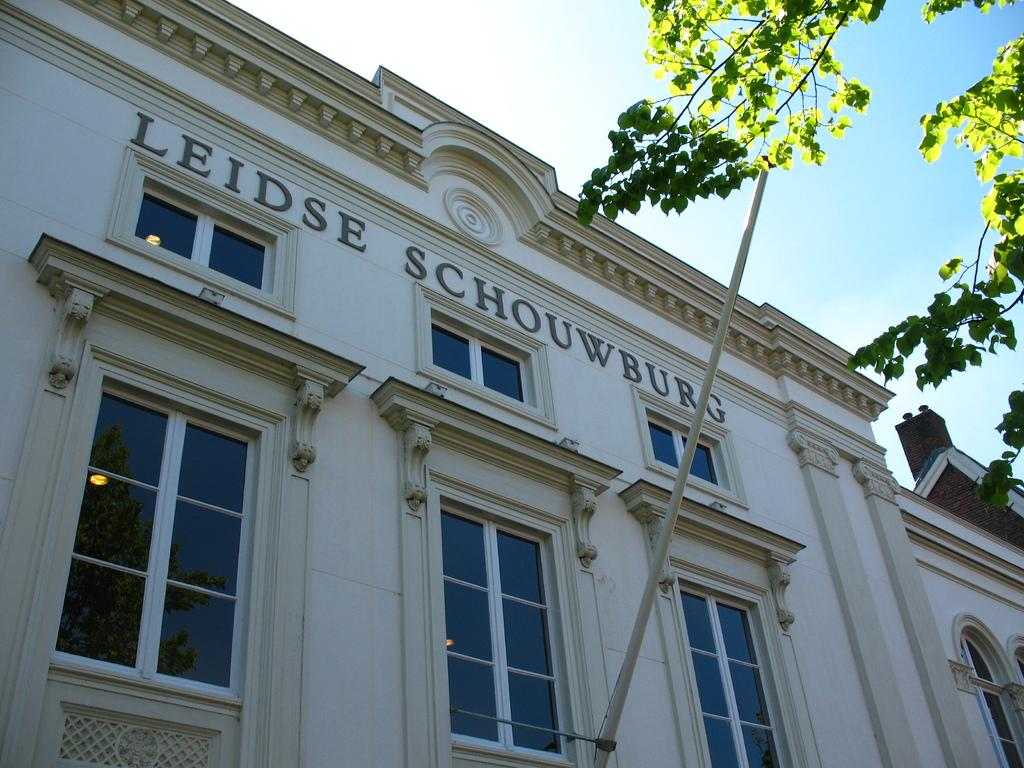What type of building is visible in the image? There is a building with glass windows in the image. What can be seen on the right side of the image? There is a tree on the right side of the image. What is visible in the background of the image? The sky is visible in the image. How does the building increase its height in the image? The building does not increase its height in the image; it is a static structure. 